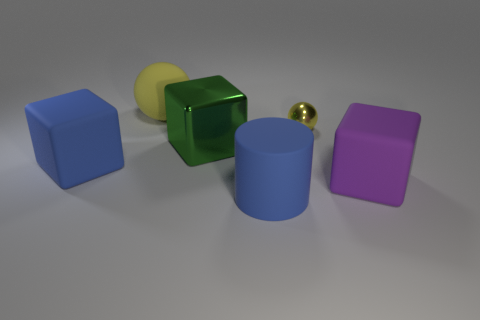Subtract all matte blocks. How many blocks are left? 1 Subtract all balls. How many objects are left? 4 Add 4 yellow rubber cubes. How many objects exist? 10 Add 1 big blue rubber objects. How many big blue rubber objects are left? 3 Add 1 balls. How many balls exist? 3 Subtract 0 red cylinders. How many objects are left? 6 Subtract all big blue things. Subtract all large rubber objects. How many objects are left? 0 